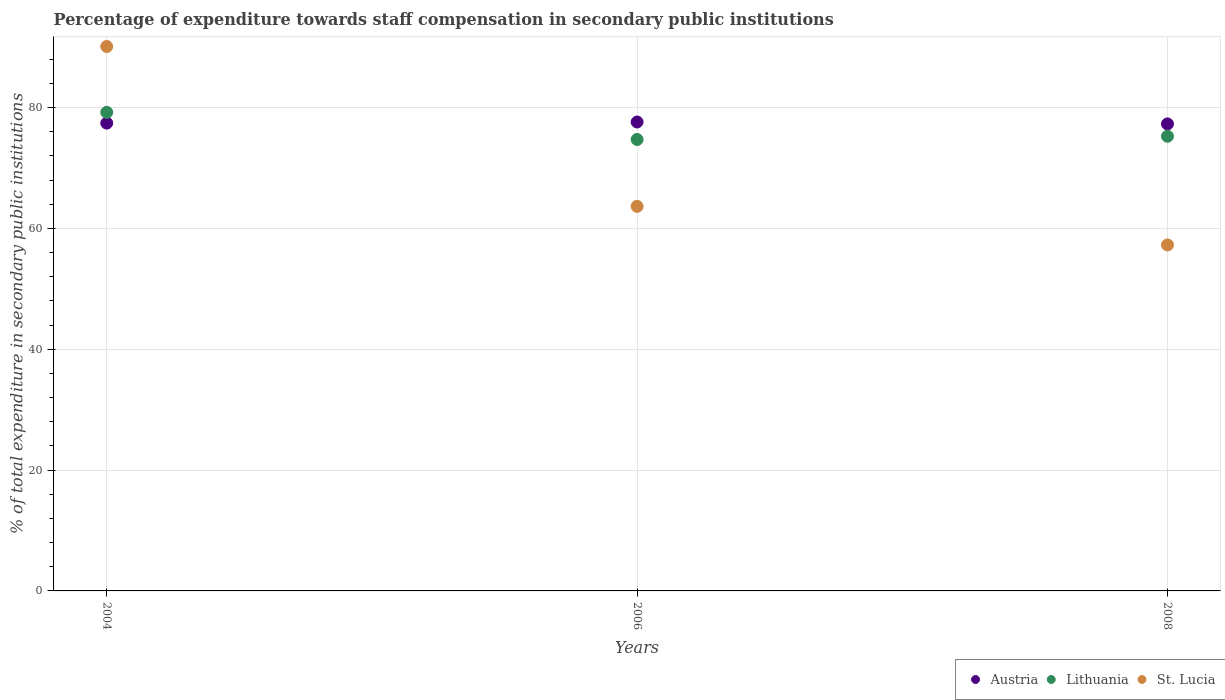What is the percentage of expenditure towards staff compensation in Austria in 2006?
Offer a terse response. 77.61. Across all years, what is the maximum percentage of expenditure towards staff compensation in Austria?
Provide a short and direct response. 77.61. Across all years, what is the minimum percentage of expenditure towards staff compensation in St. Lucia?
Provide a succinct answer. 57.26. In which year was the percentage of expenditure towards staff compensation in Austria minimum?
Make the answer very short. 2008. What is the total percentage of expenditure towards staff compensation in Lithuania in the graph?
Provide a succinct answer. 229.17. What is the difference between the percentage of expenditure towards staff compensation in Austria in 2004 and that in 2008?
Your response must be concise. 0.13. What is the difference between the percentage of expenditure towards staff compensation in Lithuania in 2006 and the percentage of expenditure towards staff compensation in St. Lucia in 2004?
Provide a short and direct response. -15.39. What is the average percentage of expenditure towards staff compensation in Lithuania per year?
Your answer should be compact. 76.39. In the year 2006, what is the difference between the percentage of expenditure towards staff compensation in Austria and percentage of expenditure towards staff compensation in St. Lucia?
Provide a succinct answer. 13.97. What is the ratio of the percentage of expenditure towards staff compensation in Austria in 2006 to that in 2008?
Offer a terse response. 1. Is the difference between the percentage of expenditure towards staff compensation in Austria in 2006 and 2008 greater than the difference between the percentage of expenditure towards staff compensation in St. Lucia in 2006 and 2008?
Provide a succinct answer. No. What is the difference between the highest and the second highest percentage of expenditure towards staff compensation in St. Lucia?
Your response must be concise. 26.46. What is the difference between the highest and the lowest percentage of expenditure towards staff compensation in Lithuania?
Your answer should be very brief. 4.49. In how many years, is the percentage of expenditure towards staff compensation in Lithuania greater than the average percentage of expenditure towards staff compensation in Lithuania taken over all years?
Your answer should be compact. 1. Is the sum of the percentage of expenditure towards staff compensation in Lithuania in 2004 and 2008 greater than the maximum percentage of expenditure towards staff compensation in St. Lucia across all years?
Give a very brief answer. Yes. Is the percentage of expenditure towards staff compensation in Lithuania strictly less than the percentage of expenditure towards staff compensation in St. Lucia over the years?
Your answer should be compact. No. How many dotlines are there?
Provide a succinct answer. 3. How many years are there in the graph?
Give a very brief answer. 3. How are the legend labels stacked?
Provide a succinct answer. Horizontal. What is the title of the graph?
Keep it short and to the point. Percentage of expenditure towards staff compensation in secondary public institutions. Does "Other small states" appear as one of the legend labels in the graph?
Keep it short and to the point. No. What is the label or title of the Y-axis?
Your response must be concise. % of total expenditure in secondary public institutions. What is the % of total expenditure in secondary public institutions in Austria in 2004?
Your answer should be very brief. 77.43. What is the % of total expenditure in secondary public institutions of Lithuania in 2004?
Offer a very short reply. 79.21. What is the % of total expenditure in secondary public institutions in St. Lucia in 2004?
Provide a succinct answer. 90.1. What is the % of total expenditure in secondary public institutions in Austria in 2006?
Provide a succinct answer. 77.61. What is the % of total expenditure in secondary public institutions of Lithuania in 2006?
Your answer should be compact. 74.71. What is the % of total expenditure in secondary public institutions of St. Lucia in 2006?
Your answer should be compact. 63.64. What is the % of total expenditure in secondary public institutions of Austria in 2008?
Keep it short and to the point. 77.29. What is the % of total expenditure in secondary public institutions of Lithuania in 2008?
Your answer should be compact. 75.25. What is the % of total expenditure in secondary public institutions in St. Lucia in 2008?
Provide a short and direct response. 57.26. Across all years, what is the maximum % of total expenditure in secondary public institutions in Austria?
Offer a terse response. 77.61. Across all years, what is the maximum % of total expenditure in secondary public institutions in Lithuania?
Your answer should be very brief. 79.21. Across all years, what is the maximum % of total expenditure in secondary public institutions of St. Lucia?
Your answer should be very brief. 90.1. Across all years, what is the minimum % of total expenditure in secondary public institutions of Austria?
Your answer should be compact. 77.29. Across all years, what is the minimum % of total expenditure in secondary public institutions in Lithuania?
Provide a succinct answer. 74.71. Across all years, what is the minimum % of total expenditure in secondary public institutions of St. Lucia?
Make the answer very short. 57.26. What is the total % of total expenditure in secondary public institutions in Austria in the graph?
Offer a terse response. 232.33. What is the total % of total expenditure in secondary public institutions of Lithuania in the graph?
Offer a terse response. 229.17. What is the total % of total expenditure in secondary public institutions in St. Lucia in the graph?
Your response must be concise. 211.01. What is the difference between the % of total expenditure in secondary public institutions of Austria in 2004 and that in 2006?
Offer a very short reply. -0.19. What is the difference between the % of total expenditure in secondary public institutions of Lithuania in 2004 and that in 2006?
Your response must be concise. 4.49. What is the difference between the % of total expenditure in secondary public institutions in St. Lucia in 2004 and that in 2006?
Make the answer very short. 26.46. What is the difference between the % of total expenditure in secondary public institutions of Austria in 2004 and that in 2008?
Ensure brevity in your answer.  0.13. What is the difference between the % of total expenditure in secondary public institutions of Lithuania in 2004 and that in 2008?
Your response must be concise. 3.96. What is the difference between the % of total expenditure in secondary public institutions of St. Lucia in 2004 and that in 2008?
Give a very brief answer. 32.84. What is the difference between the % of total expenditure in secondary public institutions of Austria in 2006 and that in 2008?
Give a very brief answer. 0.32. What is the difference between the % of total expenditure in secondary public institutions in Lithuania in 2006 and that in 2008?
Your answer should be very brief. -0.54. What is the difference between the % of total expenditure in secondary public institutions in St. Lucia in 2006 and that in 2008?
Ensure brevity in your answer.  6.38. What is the difference between the % of total expenditure in secondary public institutions of Austria in 2004 and the % of total expenditure in secondary public institutions of Lithuania in 2006?
Provide a short and direct response. 2.71. What is the difference between the % of total expenditure in secondary public institutions of Austria in 2004 and the % of total expenditure in secondary public institutions of St. Lucia in 2006?
Offer a very short reply. 13.78. What is the difference between the % of total expenditure in secondary public institutions of Lithuania in 2004 and the % of total expenditure in secondary public institutions of St. Lucia in 2006?
Offer a very short reply. 15.56. What is the difference between the % of total expenditure in secondary public institutions of Austria in 2004 and the % of total expenditure in secondary public institutions of Lithuania in 2008?
Give a very brief answer. 2.18. What is the difference between the % of total expenditure in secondary public institutions in Austria in 2004 and the % of total expenditure in secondary public institutions in St. Lucia in 2008?
Offer a terse response. 20.16. What is the difference between the % of total expenditure in secondary public institutions in Lithuania in 2004 and the % of total expenditure in secondary public institutions in St. Lucia in 2008?
Offer a terse response. 21.94. What is the difference between the % of total expenditure in secondary public institutions of Austria in 2006 and the % of total expenditure in secondary public institutions of Lithuania in 2008?
Offer a terse response. 2.36. What is the difference between the % of total expenditure in secondary public institutions of Austria in 2006 and the % of total expenditure in secondary public institutions of St. Lucia in 2008?
Your response must be concise. 20.35. What is the difference between the % of total expenditure in secondary public institutions of Lithuania in 2006 and the % of total expenditure in secondary public institutions of St. Lucia in 2008?
Your answer should be very brief. 17.45. What is the average % of total expenditure in secondary public institutions of Austria per year?
Offer a very short reply. 77.44. What is the average % of total expenditure in secondary public institutions in Lithuania per year?
Make the answer very short. 76.39. What is the average % of total expenditure in secondary public institutions of St. Lucia per year?
Your answer should be very brief. 70.34. In the year 2004, what is the difference between the % of total expenditure in secondary public institutions of Austria and % of total expenditure in secondary public institutions of Lithuania?
Offer a terse response. -1.78. In the year 2004, what is the difference between the % of total expenditure in secondary public institutions of Austria and % of total expenditure in secondary public institutions of St. Lucia?
Keep it short and to the point. -12.68. In the year 2004, what is the difference between the % of total expenditure in secondary public institutions of Lithuania and % of total expenditure in secondary public institutions of St. Lucia?
Your answer should be compact. -10.9. In the year 2006, what is the difference between the % of total expenditure in secondary public institutions in Austria and % of total expenditure in secondary public institutions in Lithuania?
Keep it short and to the point. 2.9. In the year 2006, what is the difference between the % of total expenditure in secondary public institutions of Austria and % of total expenditure in secondary public institutions of St. Lucia?
Your answer should be compact. 13.97. In the year 2006, what is the difference between the % of total expenditure in secondary public institutions of Lithuania and % of total expenditure in secondary public institutions of St. Lucia?
Your answer should be compact. 11.07. In the year 2008, what is the difference between the % of total expenditure in secondary public institutions of Austria and % of total expenditure in secondary public institutions of Lithuania?
Provide a succinct answer. 2.04. In the year 2008, what is the difference between the % of total expenditure in secondary public institutions of Austria and % of total expenditure in secondary public institutions of St. Lucia?
Ensure brevity in your answer.  20.03. In the year 2008, what is the difference between the % of total expenditure in secondary public institutions in Lithuania and % of total expenditure in secondary public institutions in St. Lucia?
Your answer should be very brief. 17.99. What is the ratio of the % of total expenditure in secondary public institutions in Austria in 2004 to that in 2006?
Ensure brevity in your answer.  1. What is the ratio of the % of total expenditure in secondary public institutions in Lithuania in 2004 to that in 2006?
Offer a terse response. 1.06. What is the ratio of the % of total expenditure in secondary public institutions in St. Lucia in 2004 to that in 2006?
Keep it short and to the point. 1.42. What is the ratio of the % of total expenditure in secondary public institutions in Austria in 2004 to that in 2008?
Your response must be concise. 1. What is the ratio of the % of total expenditure in secondary public institutions in Lithuania in 2004 to that in 2008?
Make the answer very short. 1.05. What is the ratio of the % of total expenditure in secondary public institutions in St. Lucia in 2004 to that in 2008?
Offer a terse response. 1.57. What is the ratio of the % of total expenditure in secondary public institutions in Austria in 2006 to that in 2008?
Give a very brief answer. 1. What is the ratio of the % of total expenditure in secondary public institutions in St. Lucia in 2006 to that in 2008?
Provide a succinct answer. 1.11. What is the difference between the highest and the second highest % of total expenditure in secondary public institutions of Austria?
Offer a terse response. 0.19. What is the difference between the highest and the second highest % of total expenditure in secondary public institutions in Lithuania?
Make the answer very short. 3.96. What is the difference between the highest and the second highest % of total expenditure in secondary public institutions of St. Lucia?
Make the answer very short. 26.46. What is the difference between the highest and the lowest % of total expenditure in secondary public institutions in Austria?
Offer a very short reply. 0.32. What is the difference between the highest and the lowest % of total expenditure in secondary public institutions of Lithuania?
Ensure brevity in your answer.  4.49. What is the difference between the highest and the lowest % of total expenditure in secondary public institutions in St. Lucia?
Provide a succinct answer. 32.84. 